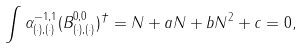Convert formula to latex. <formula><loc_0><loc_0><loc_500><loc_500>\int \alpha _ { ( \cdot ) , ( \cdot ) } ^ { - 1 , 1 } ( B _ { ( \cdot ) , ( \cdot ) } ^ { 0 , 0 } ) ^ { \dagger } = N + a N + b N ^ { 2 } + c = 0 ,</formula> 